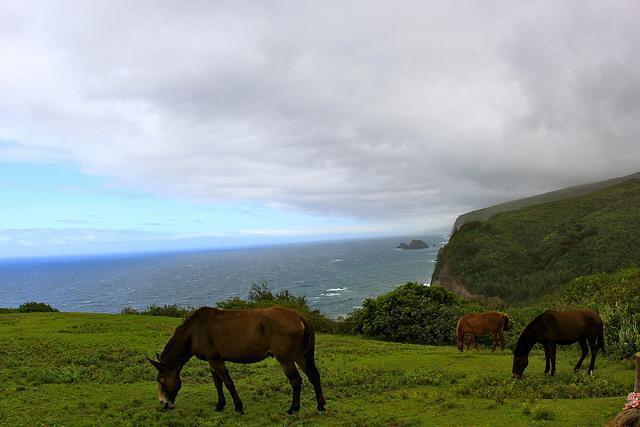How many horses are there?
Give a very brief answer. 3. How many horses in the picture?
Give a very brief answer. 3. 